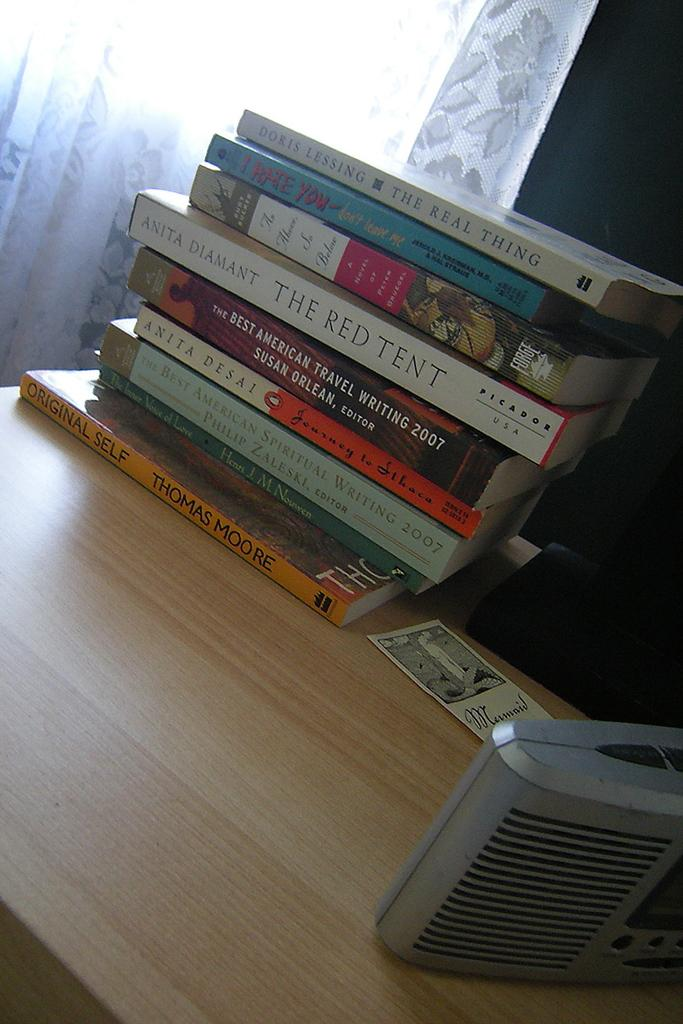<image>
Describe the image concisely. A stack of paperback books sits on a desk, the top one being The Real Thing. 